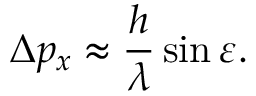Convert formula to latex. <formula><loc_0><loc_0><loc_500><loc_500>\Delta p _ { x } \approx { \frac { h } { \lambda } } \sin \varepsilon .</formula> 